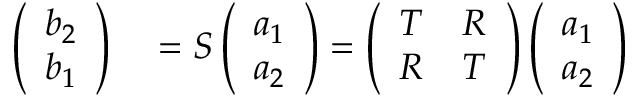<formula> <loc_0><loc_0><loc_500><loc_500>\begin{array} { r l } { \left ( \begin{array} { l } { b _ { 2 } } \\ { b _ { 1 } } \end{array} \right ) } & = S \left ( \begin{array} { l } { a _ { 1 } } \\ { a _ { 2 } } \end{array} \right ) = \left ( \begin{array} { l l } { T } & { R } \\ { R } & { T } \end{array} \right ) \left ( \begin{array} { l } { a _ { 1 } } \\ { a _ { 2 } } \end{array} \right ) } \end{array}</formula> 